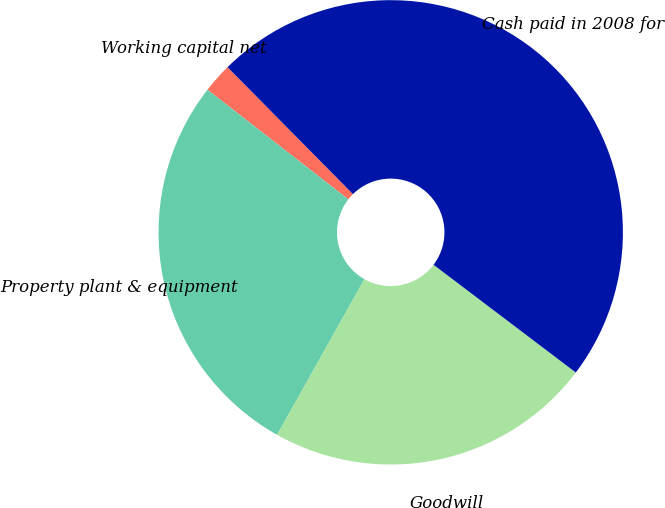<chart> <loc_0><loc_0><loc_500><loc_500><pie_chart><fcel>Working capital net<fcel>Property plant & equipment<fcel>Goodwill<fcel>Cash paid in 2008 for<nl><fcel>2.07%<fcel>27.39%<fcel>22.82%<fcel>47.72%<nl></chart> 